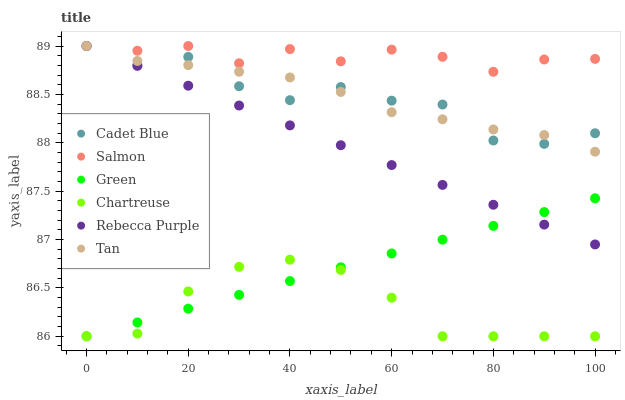Does Chartreuse have the minimum area under the curve?
Answer yes or no. Yes. Does Salmon have the maximum area under the curve?
Answer yes or no. Yes. Does Salmon have the minimum area under the curve?
Answer yes or no. No. Does Chartreuse have the maximum area under the curve?
Answer yes or no. No. Is Rebecca Purple the smoothest?
Answer yes or no. Yes. Is Cadet Blue the roughest?
Answer yes or no. Yes. Is Salmon the smoothest?
Answer yes or no. No. Is Salmon the roughest?
Answer yes or no. No. Does Chartreuse have the lowest value?
Answer yes or no. Yes. Does Salmon have the lowest value?
Answer yes or no. No. Does Tan have the highest value?
Answer yes or no. Yes. Does Chartreuse have the highest value?
Answer yes or no. No. Is Chartreuse less than Tan?
Answer yes or no. Yes. Is Salmon greater than Chartreuse?
Answer yes or no. Yes. Does Rebecca Purple intersect Salmon?
Answer yes or no. Yes. Is Rebecca Purple less than Salmon?
Answer yes or no. No. Is Rebecca Purple greater than Salmon?
Answer yes or no. No. Does Chartreuse intersect Tan?
Answer yes or no. No. 